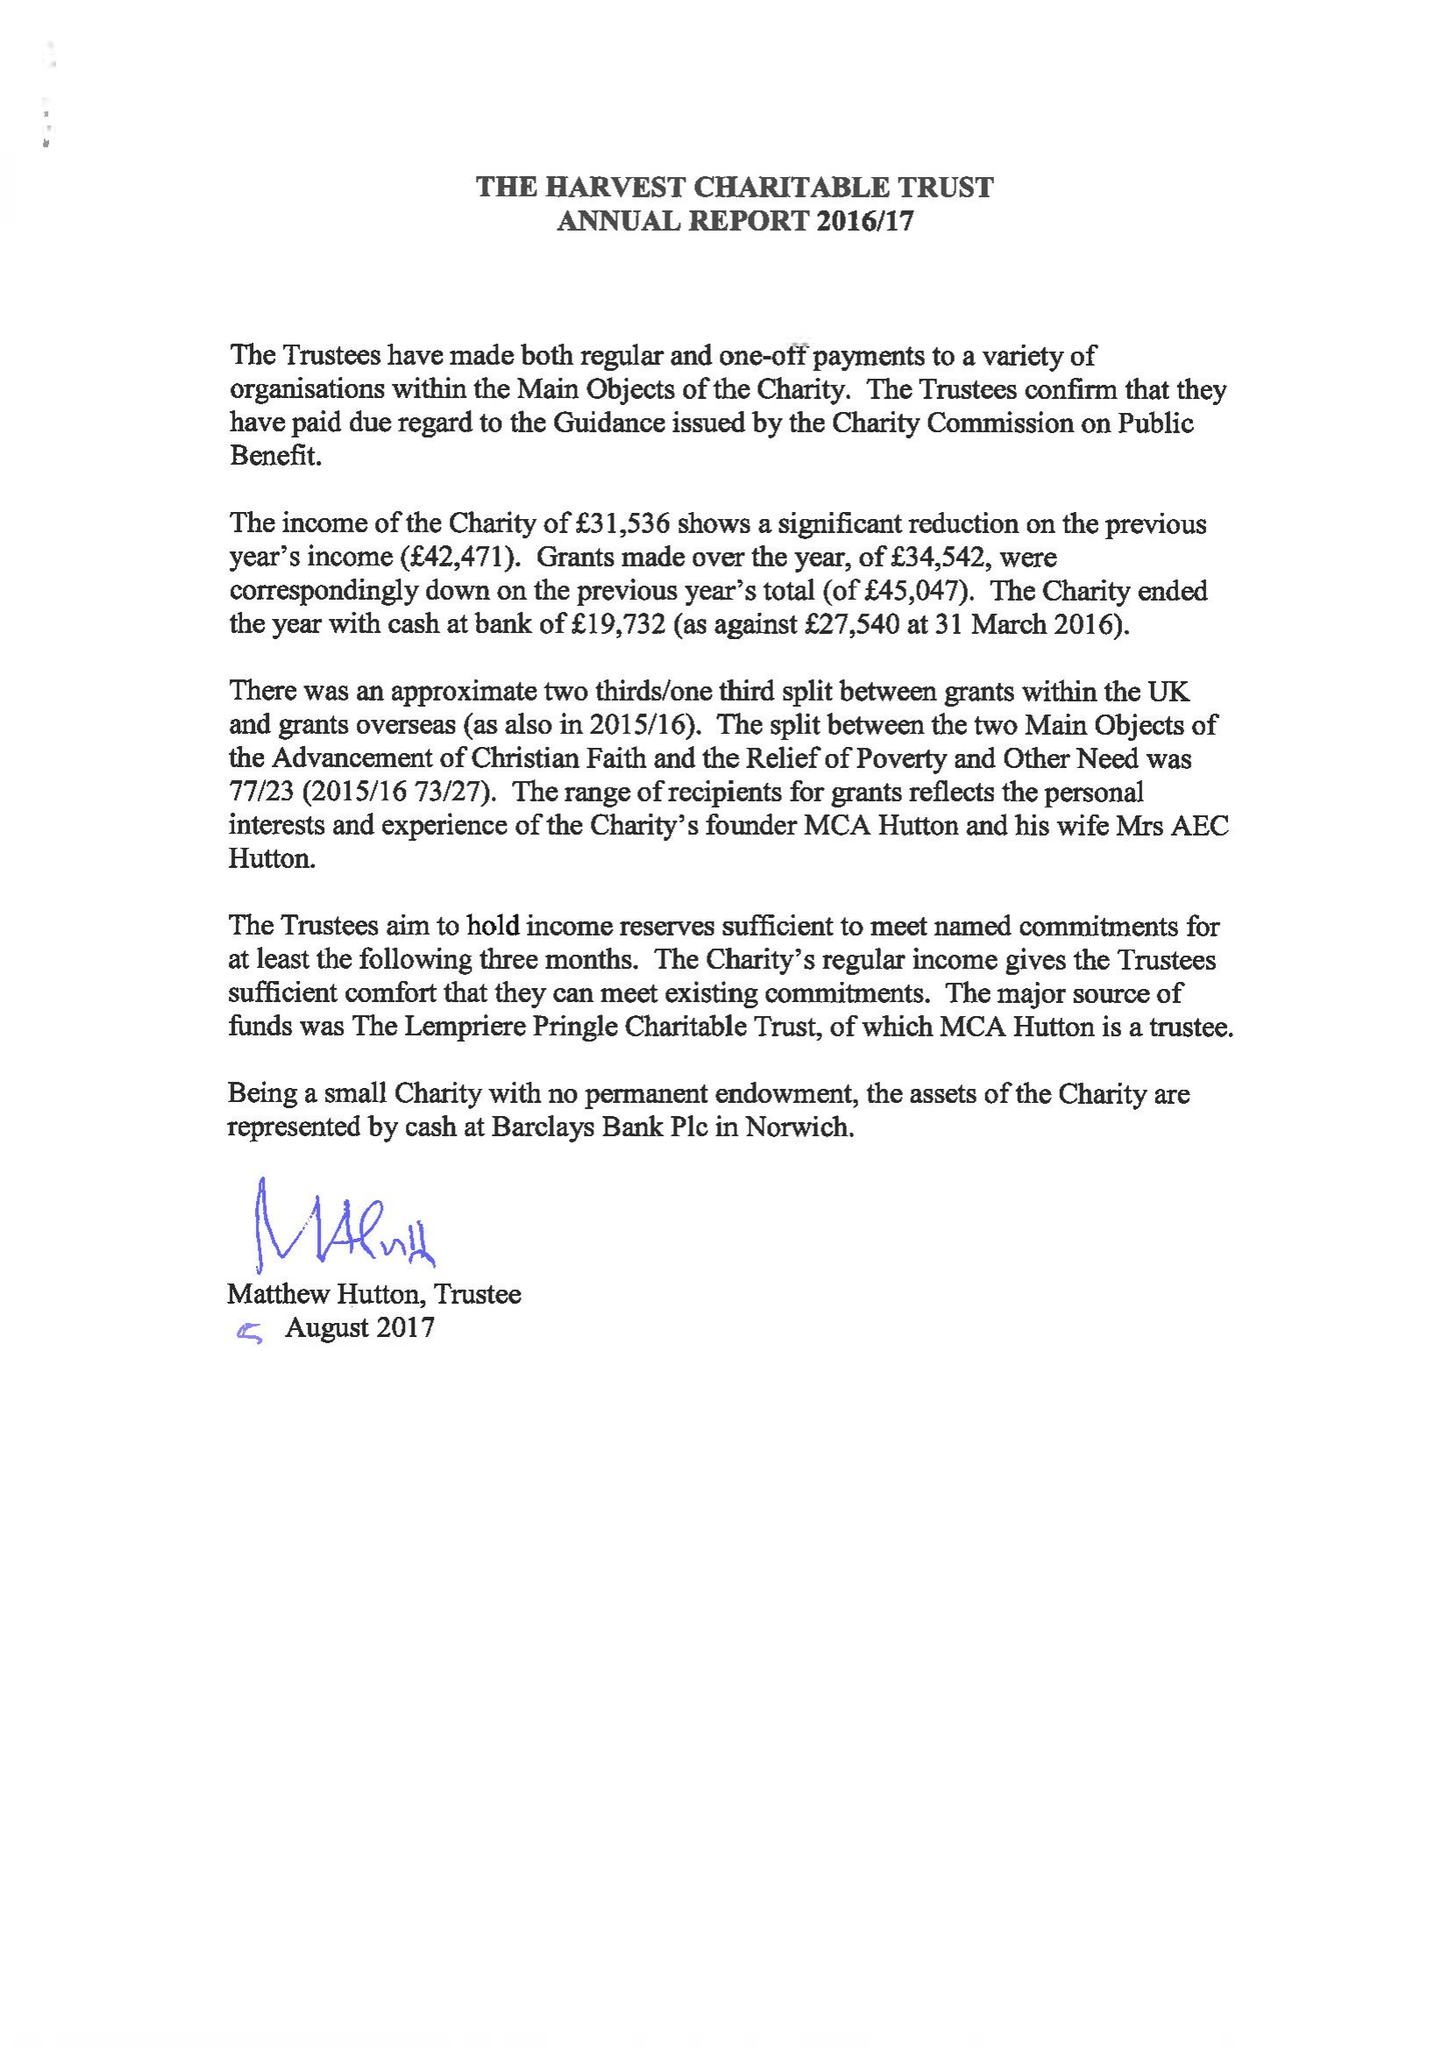What is the value for the spending_annually_in_british_pounds?
Answer the question using a single word or phrase. 34544.00 